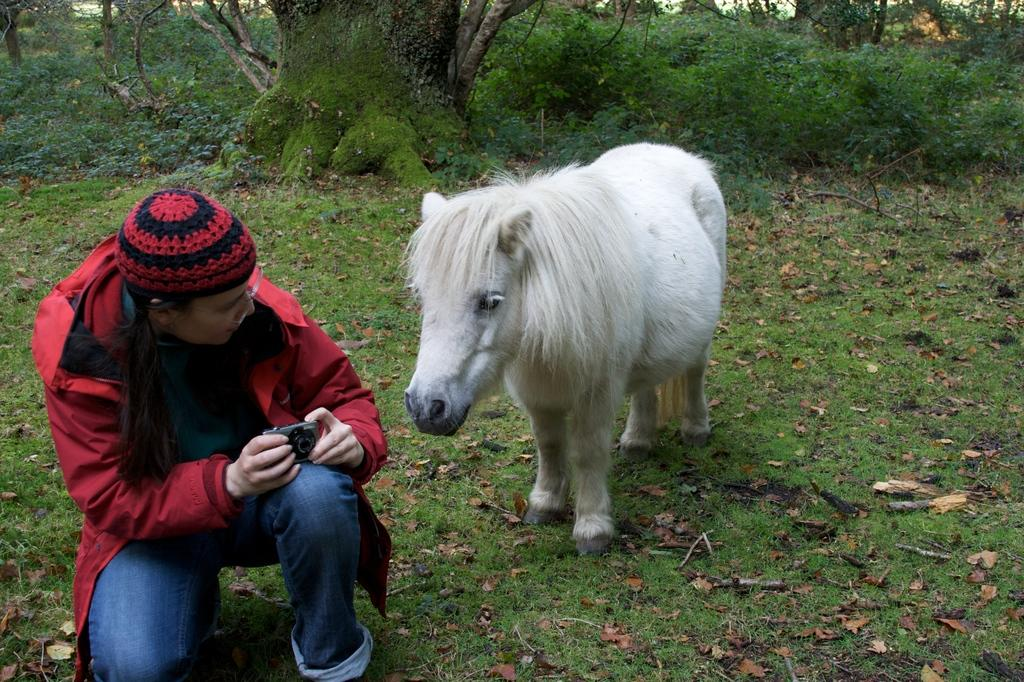What is the main subject of the image? There is a person in the image. What is the person wearing? The person is wearing a red jacket. What is the person holding? The person is holding a camera. What can be seen behind the person? There is an animal and trees behind the person. What is the name of the person in the image? The provided facts do not include the name of the person, so we cannot determine their name from the image. Can you show me the person pushing the animal in the image? There is no indication in the image that the person is pushing the animal, nor is there any visible action of pushing. 